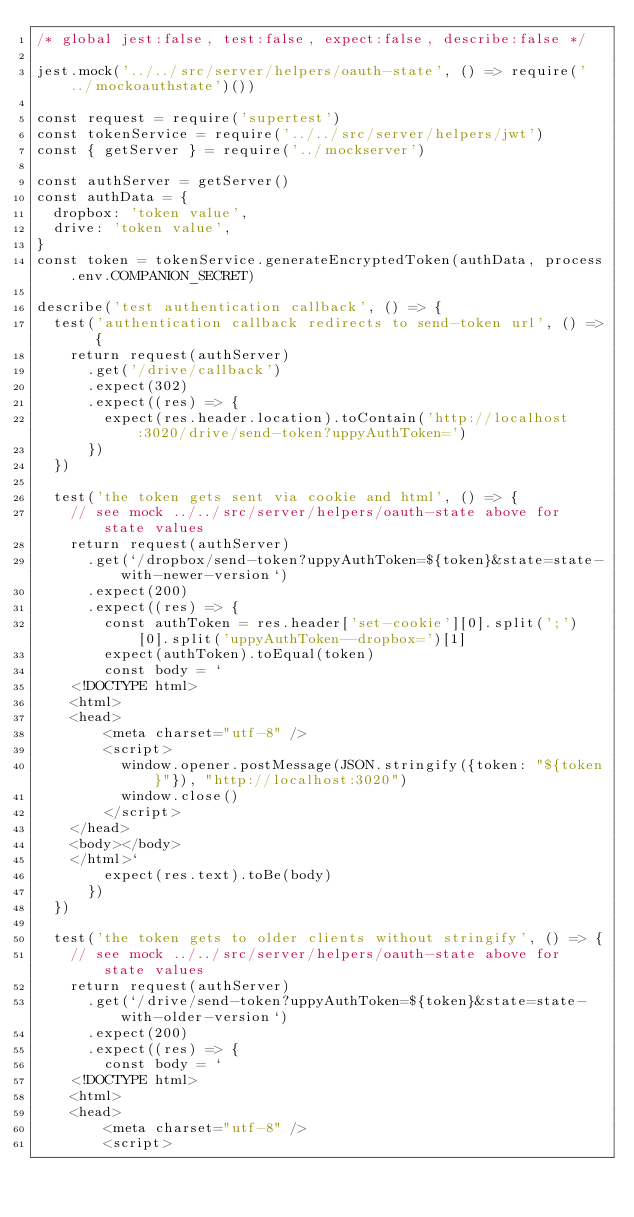<code> <loc_0><loc_0><loc_500><loc_500><_JavaScript_>/* global jest:false, test:false, expect:false, describe:false */

jest.mock('../../src/server/helpers/oauth-state', () => require('../mockoauthstate')())

const request = require('supertest')
const tokenService = require('../../src/server/helpers/jwt')
const { getServer } = require('../mockserver')

const authServer = getServer()
const authData = {
  dropbox: 'token value',
  drive: 'token value',
}
const token = tokenService.generateEncryptedToken(authData, process.env.COMPANION_SECRET)

describe('test authentication callback', () => {
  test('authentication callback redirects to send-token url', () => {
    return request(authServer)
      .get('/drive/callback')
      .expect(302)
      .expect((res) => {
        expect(res.header.location).toContain('http://localhost:3020/drive/send-token?uppyAuthToken=')
      })
  })

  test('the token gets sent via cookie and html', () => {
    // see mock ../../src/server/helpers/oauth-state above for state values
    return request(authServer)
      .get(`/dropbox/send-token?uppyAuthToken=${token}&state=state-with-newer-version`)
      .expect(200)
      .expect((res) => {
        const authToken = res.header['set-cookie'][0].split(';')[0].split('uppyAuthToken--dropbox=')[1]
        expect(authToken).toEqual(token)
        const body = `
    <!DOCTYPE html>
    <html>
    <head>
        <meta charset="utf-8" />
        <script>
          window.opener.postMessage(JSON.stringify({token: "${token}"}), "http://localhost:3020")
          window.close()
        </script>
    </head>
    <body></body>
    </html>`
        expect(res.text).toBe(body)
      })
  })

  test('the token gets to older clients without stringify', () => {
    // see mock ../../src/server/helpers/oauth-state above for state values
    return request(authServer)
      .get(`/drive/send-token?uppyAuthToken=${token}&state=state-with-older-version`)
      .expect(200)
      .expect((res) => {
        const body = `
    <!DOCTYPE html>
    <html>
    <head>
        <meta charset="utf-8" />
        <script></code> 